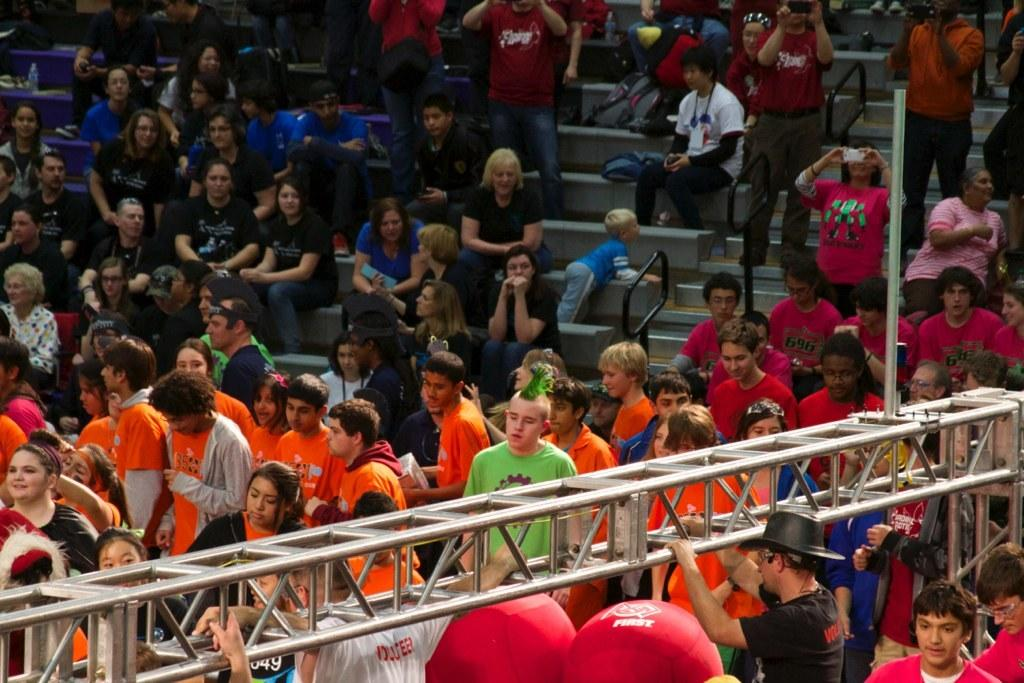How many people are in the image? There is a group of persons in the image, but the exact number is not specified. What are the persons in the image doing? Some of the persons are sitting on a staircase. What else can be seen in the image besides the persons? There is a road visible in the image. What type of appliance can be seen on the farm in the image? There is no farm or appliance present in the image; it features a group of persons sitting on a staircase and a road. 